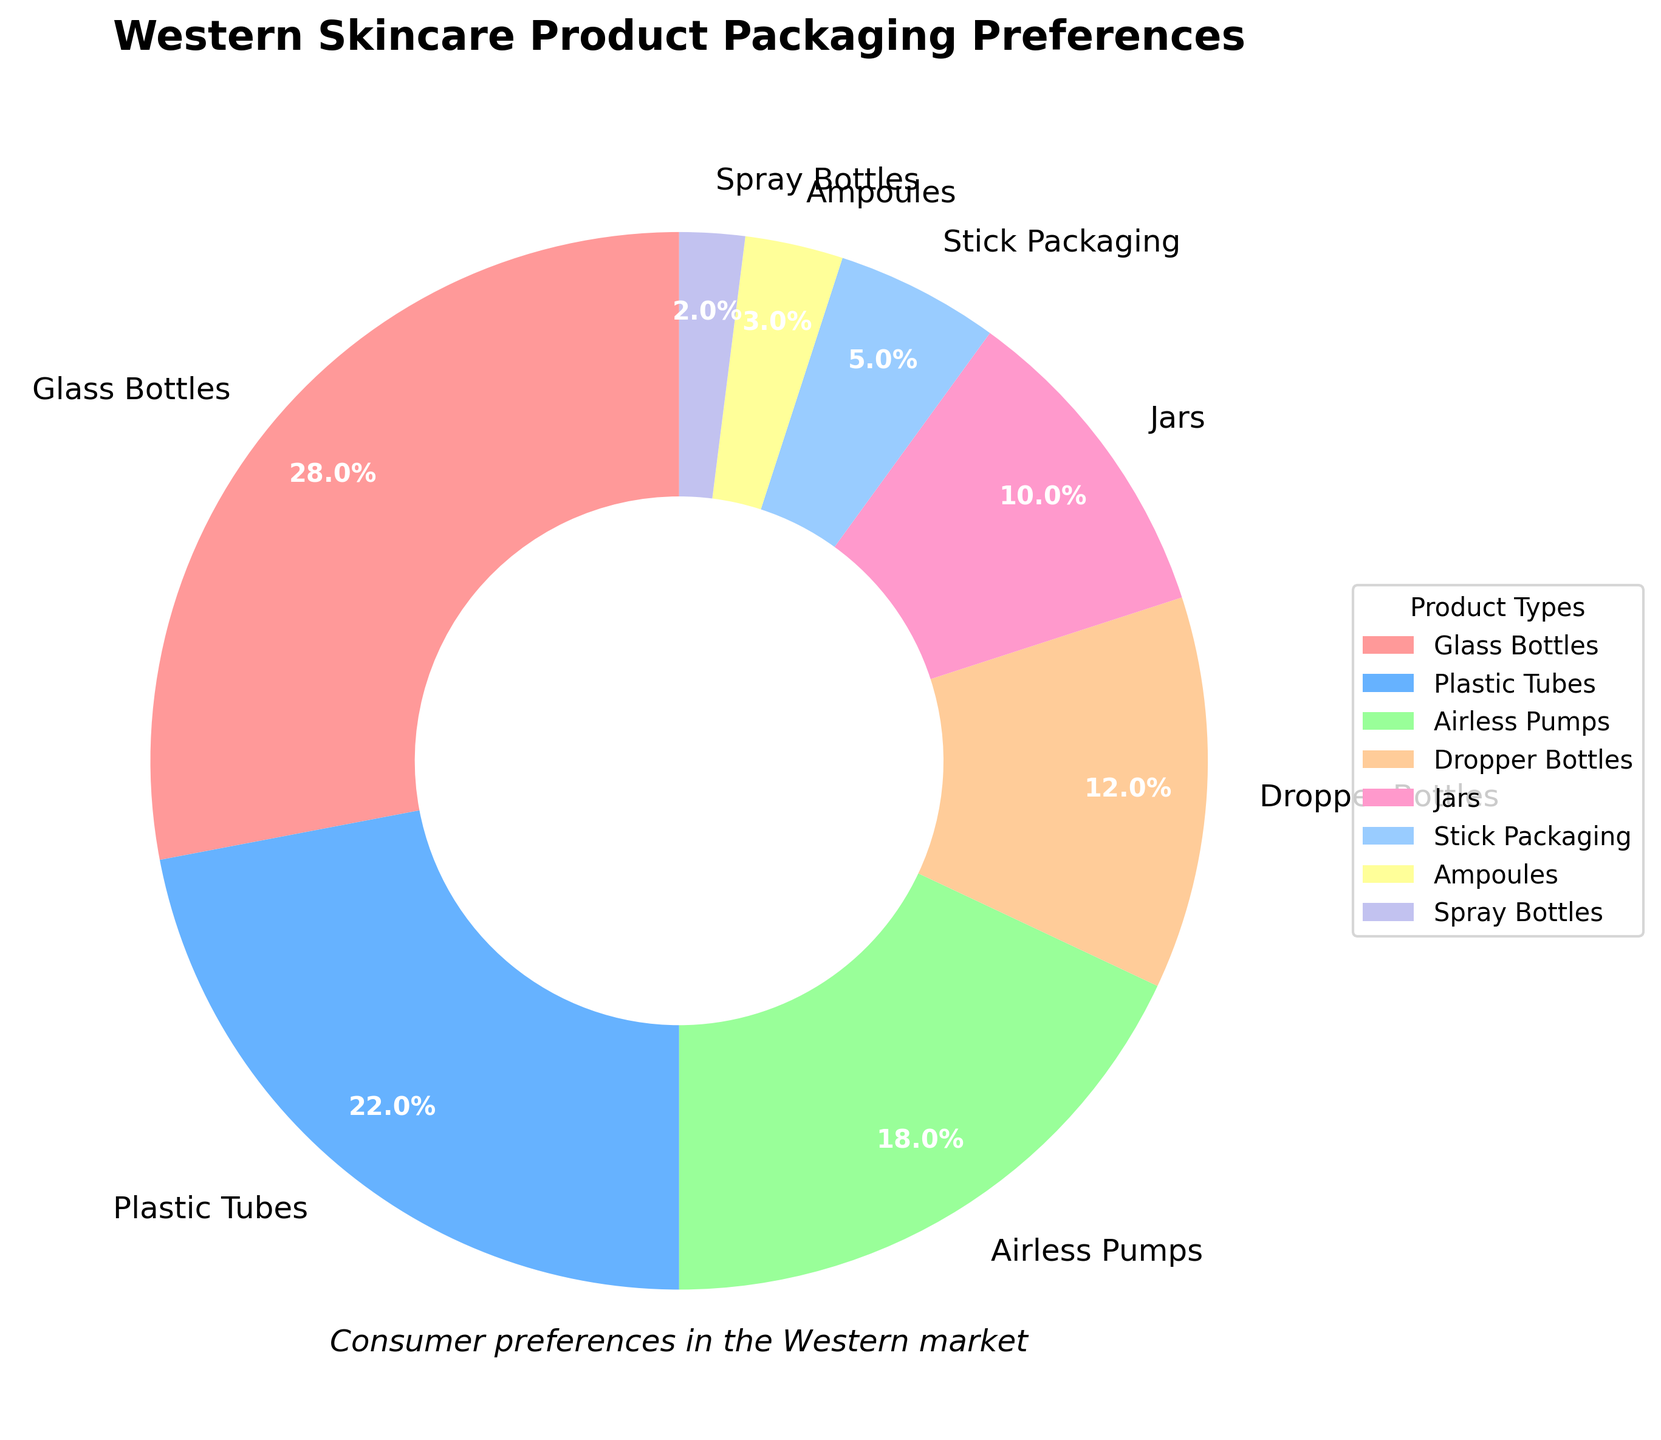What's the most preferred packaging type for Western skincare products according to the chart? The chart shows different packaging types along with their respective percentages. The packaging type with the highest percentage is the most preferred. The chart indicates that "Glass Bottles" have the highest percentage at 28%.
Answer: Glass Bottles Which packaging type has the smallest consumer preference? The packaging types are listed along with their percentages in the chart. The packaging type with the smallest percentage is the least preferred. "Spray Bottles" have the smallest consumer preference at 2%.
Answer: Spray Bottles How much more popular are Glass Bottles compared to Jars? To calculate this, subtract the percentage of Jars from the percentage of Glass Bottles. Glass Bottles have a percentage of 28%, and Jars have 10%. The difference is 28% - 10%.
Answer: 18% What is the combined preference percentage for Airless Pumps and Dropper Bottles? Add the percentages of Airless Pumps and Dropper Bottles. Airless Pumps have 18% and Dropper Bottles have 12%. The combined percentage is 18% + 12%.
Answer: 30% Which packaging type is more preferred: Plastic Tubes or Stick Packaging? Compare the percentages of Plastic Tubes and Stick Packaging. Plastic Tubes have 22%, while Stick Packaging has 5%. Plastic Tubes have a higher preference.
Answer: Plastic Tubes What percentage of consumers prefer Glass Bottles or Plastic Tubes? Add the percentages of Glass Bottles and Plastic Tubes. Glass Bottles have 28% and Plastic Tubes have 22%. The combined preference is 28% + 22%.
Answer: 50% What is the median preference percentage among all the packaging types? To find the median, list out all the percentages in ascending order: 2, 3, 5, 10, 12, 18, 22, 28. The median is the average of the 4th and 5th values: (10 + 12) / 2.
Answer: 11% How does the preference for Airless Pumps compare with Dropper Bottles? Compare the percentages directly. Airless Pumps have 18% and Dropper Bottles have 12%, meaning Airless Pumps are more preferred.
Answer: Airless Pumps What proportion of consumers prefer packaging types other than Glass Bottles? Subtract the percentage of people who prefer Glass Bottles from the total (100%). Glass Bottles have 28%, so 100% - 28% gives the proportion of consumers who prefer other packaging types.
Answer: 72% What percentage of consumer preference is represented by the three least popular packaging types? Add the percentages of the three least popular packaging types, which are Spray Bottles (2%), Ampoules (3%), and Stick Packaging (5%). The total is 2% + 3% + 5%.
Answer: 10% 